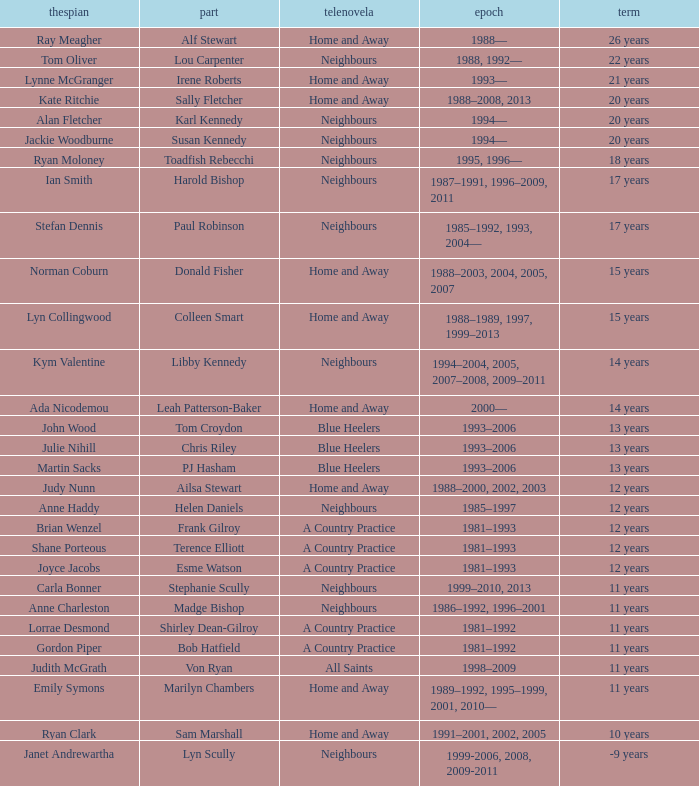What was the length of time joyce jacobs spent portraying her part on the show? 12 years. 